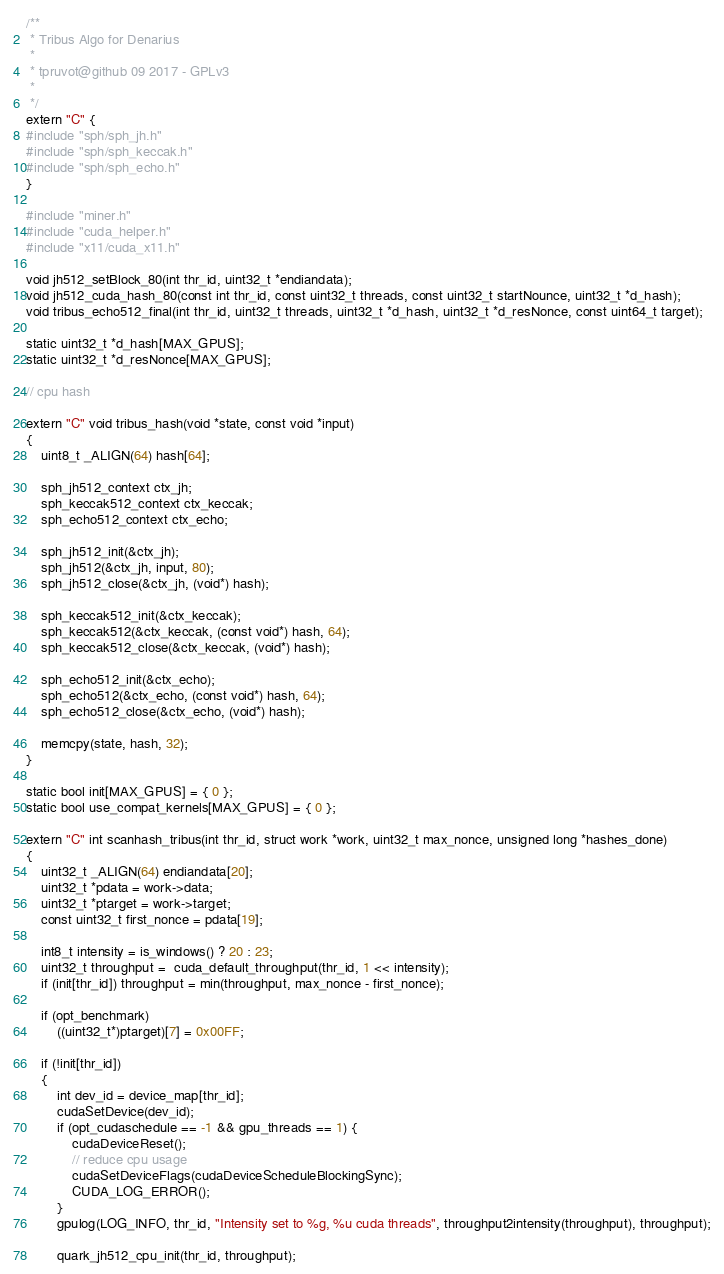Convert code to text. <code><loc_0><loc_0><loc_500><loc_500><_Cuda_>/**
 * Tribus Algo for Denarius
 *
 * tpruvot@github 09 2017 - GPLv3
 *
 */
extern "C" {
#include "sph/sph_jh.h"
#include "sph/sph_keccak.h"
#include "sph/sph_echo.h"
}

#include "miner.h"
#include "cuda_helper.h"
#include "x11/cuda_x11.h"

void jh512_setBlock_80(int thr_id, uint32_t *endiandata);
void jh512_cuda_hash_80(const int thr_id, const uint32_t threads, const uint32_t startNounce, uint32_t *d_hash);
void tribus_echo512_final(int thr_id, uint32_t threads, uint32_t *d_hash, uint32_t *d_resNonce, const uint64_t target);

static uint32_t *d_hash[MAX_GPUS];
static uint32_t *d_resNonce[MAX_GPUS];

// cpu hash

extern "C" void tribus_hash(void *state, const void *input)
{
	uint8_t _ALIGN(64) hash[64];

	sph_jh512_context ctx_jh;
	sph_keccak512_context ctx_keccak;
	sph_echo512_context ctx_echo;

	sph_jh512_init(&ctx_jh);
	sph_jh512(&ctx_jh, input, 80);
	sph_jh512_close(&ctx_jh, (void*) hash);

	sph_keccak512_init(&ctx_keccak);
	sph_keccak512(&ctx_keccak, (const void*) hash, 64);
	sph_keccak512_close(&ctx_keccak, (void*) hash);

	sph_echo512_init(&ctx_echo);
	sph_echo512(&ctx_echo, (const void*) hash, 64);
	sph_echo512_close(&ctx_echo, (void*) hash);

	memcpy(state, hash, 32);
}

static bool init[MAX_GPUS] = { 0 };
static bool use_compat_kernels[MAX_GPUS] = { 0 };

extern "C" int scanhash_tribus(int thr_id, struct work *work, uint32_t max_nonce, unsigned long *hashes_done)
{
	uint32_t _ALIGN(64) endiandata[20];
	uint32_t *pdata = work->data;
	uint32_t *ptarget = work->target;
	const uint32_t first_nonce = pdata[19];

	int8_t intensity = is_windows() ? 20 : 23;
	uint32_t throughput =  cuda_default_throughput(thr_id, 1 << intensity);
	if (init[thr_id]) throughput = min(throughput, max_nonce - first_nonce);

	if (opt_benchmark)
		((uint32_t*)ptarget)[7] = 0x00FF;

	if (!init[thr_id])
	{
		int dev_id = device_map[thr_id];
		cudaSetDevice(dev_id);
		if (opt_cudaschedule == -1 && gpu_threads == 1) {
			cudaDeviceReset();
			// reduce cpu usage
			cudaSetDeviceFlags(cudaDeviceScheduleBlockingSync);
			CUDA_LOG_ERROR();
		}
		gpulog(LOG_INFO, thr_id, "Intensity set to %g, %u cuda threads", throughput2intensity(throughput), throughput);

		quark_jh512_cpu_init(thr_id, throughput);</code> 